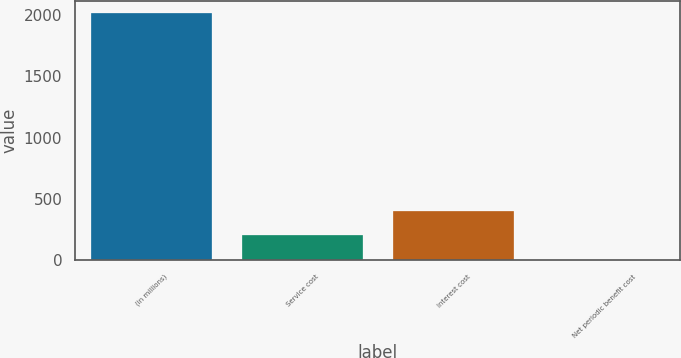Convert chart. <chart><loc_0><loc_0><loc_500><loc_500><bar_chart><fcel>(in millions)<fcel>Service cost<fcel>Interest cost<fcel>Net periodic benefit cost<nl><fcel>2013<fcel>204<fcel>405<fcel>3<nl></chart> 